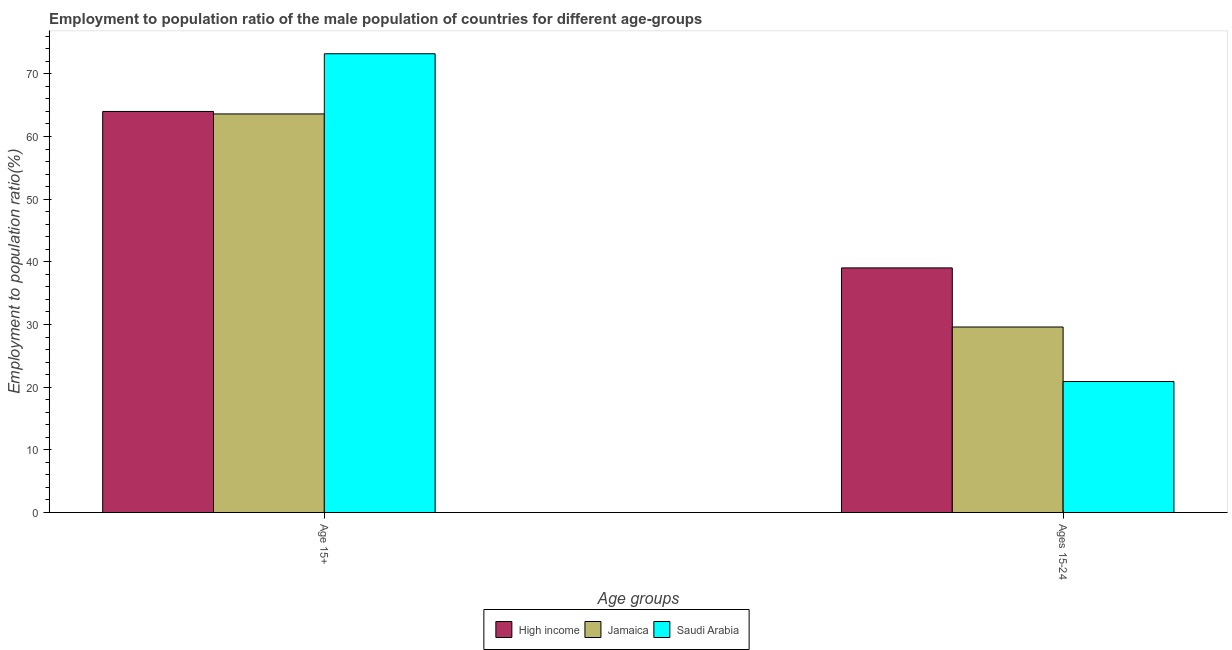Are the number of bars on each tick of the X-axis equal?
Provide a succinct answer. Yes. How many bars are there on the 2nd tick from the left?
Your answer should be compact. 3. How many bars are there on the 1st tick from the right?
Your answer should be compact. 3. What is the label of the 2nd group of bars from the left?
Your answer should be compact. Ages 15-24. What is the employment to population ratio(age 15+) in High income?
Make the answer very short. 63.99. Across all countries, what is the maximum employment to population ratio(age 15+)?
Your answer should be very brief. 73.2. Across all countries, what is the minimum employment to population ratio(age 15-24)?
Provide a succinct answer. 20.9. In which country was the employment to population ratio(age 15-24) maximum?
Make the answer very short. High income. In which country was the employment to population ratio(age 15-24) minimum?
Provide a succinct answer. Saudi Arabia. What is the total employment to population ratio(age 15+) in the graph?
Provide a succinct answer. 200.79. What is the difference between the employment to population ratio(age 15+) in High income and that in Jamaica?
Make the answer very short. 0.39. What is the difference between the employment to population ratio(age 15-24) in Jamaica and the employment to population ratio(age 15+) in High income?
Offer a very short reply. -34.39. What is the average employment to population ratio(age 15-24) per country?
Offer a very short reply. 29.84. What is the difference between the employment to population ratio(age 15-24) and employment to population ratio(age 15+) in Saudi Arabia?
Your answer should be compact. -52.3. What is the ratio of the employment to population ratio(age 15-24) in High income to that in Jamaica?
Your answer should be compact. 1.32. In how many countries, is the employment to population ratio(age 15-24) greater than the average employment to population ratio(age 15-24) taken over all countries?
Offer a terse response. 1. What does the 1st bar from the left in Ages 15-24 represents?
Give a very brief answer. High income. How many bars are there?
Your answer should be very brief. 6. What is the difference between two consecutive major ticks on the Y-axis?
Offer a terse response. 10. Are the values on the major ticks of Y-axis written in scientific E-notation?
Offer a terse response. No. Does the graph contain grids?
Your answer should be compact. No. Where does the legend appear in the graph?
Your answer should be compact. Bottom center. How many legend labels are there?
Your response must be concise. 3. What is the title of the graph?
Give a very brief answer. Employment to population ratio of the male population of countries for different age-groups. What is the label or title of the X-axis?
Make the answer very short. Age groups. What is the label or title of the Y-axis?
Give a very brief answer. Employment to population ratio(%). What is the Employment to population ratio(%) of High income in Age 15+?
Your answer should be very brief. 63.99. What is the Employment to population ratio(%) of Jamaica in Age 15+?
Provide a succinct answer. 63.6. What is the Employment to population ratio(%) of Saudi Arabia in Age 15+?
Ensure brevity in your answer.  73.2. What is the Employment to population ratio(%) in High income in Ages 15-24?
Your answer should be compact. 39.03. What is the Employment to population ratio(%) of Jamaica in Ages 15-24?
Provide a succinct answer. 29.6. What is the Employment to population ratio(%) of Saudi Arabia in Ages 15-24?
Your answer should be compact. 20.9. Across all Age groups, what is the maximum Employment to population ratio(%) in High income?
Ensure brevity in your answer.  63.99. Across all Age groups, what is the maximum Employment to population ratio(%) of Jamaica?
Make the answer very short. 63.6. Across all Age groups, what is the maximum Employment to population ratio(%) in Saudi Arabia?
Your answer should be very brief. 73.2. Across all Age groups, what is the minimum Employment to population ratio(%) of High income?
Ensure brevity in your answer.  39.03. Across all Age groups, what is the minimum Employment to population ratio(%) of Jamaica?
Offer a terse response. 29.6. Across all Age groups, what is the minimum Employment to population ratio(%) in Saudi Arabia?
Your answer should be compact. 20.9. What is the total Employment to population ratio(%) of High income in the graph?
Keep it short and to the point. 103.02. What is the total Employment to population ratio(%) of Jamaica in the graph?
Offer a very short reply. 93.2. What is the total Employment to population ratio(%) in Saudi Arabia in the graph?
Offer a terse response. 94.1. What is the difference between the Employment to population ratio(%) of High income in Age 15+ and that in Ages 15-24?
Keep it short and to the point. 24.96. What is the difference between the Employment to population ratio(%) of Saudi Arabia in Age 15+ and that in Ages 15-24?
Your answer should be very brief. 52.3. What is the difference between the Employment to population ratio(%) of High income in Age 15+ and the Employment to population ratio(%) of Jamaica in Ages 15-24?
Make the answer very short. 34.39. What is the difference between the Employment to population ratio(%) in High income in Age 15+ and the Employment to population ratio(%) in Saudi Arabia in Ages 15-24?
Your answer should be very brief. 43.09. What is the difference between the Employment to population ratio(%) in Jamaica in Age 15+ and the Employment to population ratio(%) in Saudi Arabia in Ages 15-24?
Your answer should be compact. 42.7. What is the average Employment to population ratio(%) of High income per Age groups?
Provide a short and direct response. 51.51. What is the average Employment to population ratio(%) of Jamaica per Age groups?
Provide a short and direct response. 46.6. What is the average Employment to population ratio(%) of Saudi Arabia per Age groups?
Your answer should be compact. 47.05. What is the difference between the Employment to population ratio(%) of High income and Employment to population ratio(%) of Jamaica in Age 15+?
Offer a terse response. 0.39. What is the difference between the Employment to population ratio(%) of High income and Employment to population ratio(%) of Saudi Arabia in Age 15+?
Your answer should be compact. -9.21. What is the difference between the Employment to population ratio(%) in High income and Employment to population ratio(%) in Jamaica in Ages 15-24?
Keep it short and to the point. 9.43. What is the difference between the Employment to population ratio(%) of High income and Employment to population ratio(%) of Saudi Arabia in Ages 15-24?
Make the answer very short. 18.13. What is the difference between the Employment to population ratio(%) in Jamaica and Employment to population ratio(%) in Saudi Arabia in Ages 15-24?
Offer a very short reply. 8.7. What is the ratio of the Employment to population ratio(%) of High income in Age 15+ to that in Ages 15-24?
Give a very brief answer. 1.64. What is the ratio of the Employment to population ratio(%) in Jamaica in Age 15+ to that in Ages 15-24?
Your answer should be compact. 2.15. What is the ratio of the Employment to population ratio(%) in Saudi Arabia in Age 15+ to that in Ages 15-24?
Your answer should be very brief. 3.5. What is the difference between the highest and the second highest Employment to population ratio(%) in High income?
Your response must be concise. 24.96. What is the difference between the highest and the second highest Employment to population ratio(%) of Saudi Arabia?
Your response must be concise. 52.3. What is the difference between the highest and the lowest Employment to population ratio(%) of High income?
Your response must be concise. 24.96. What is the difference between the highest and the lowest Employment to population ratio(%) in Jamaica?
Your answer should be compact. 34. What is the difference between the highest and the lowest Employment to population ratio(%) of Saudi Arabia?
Your answer should be very brief. 52.3. 